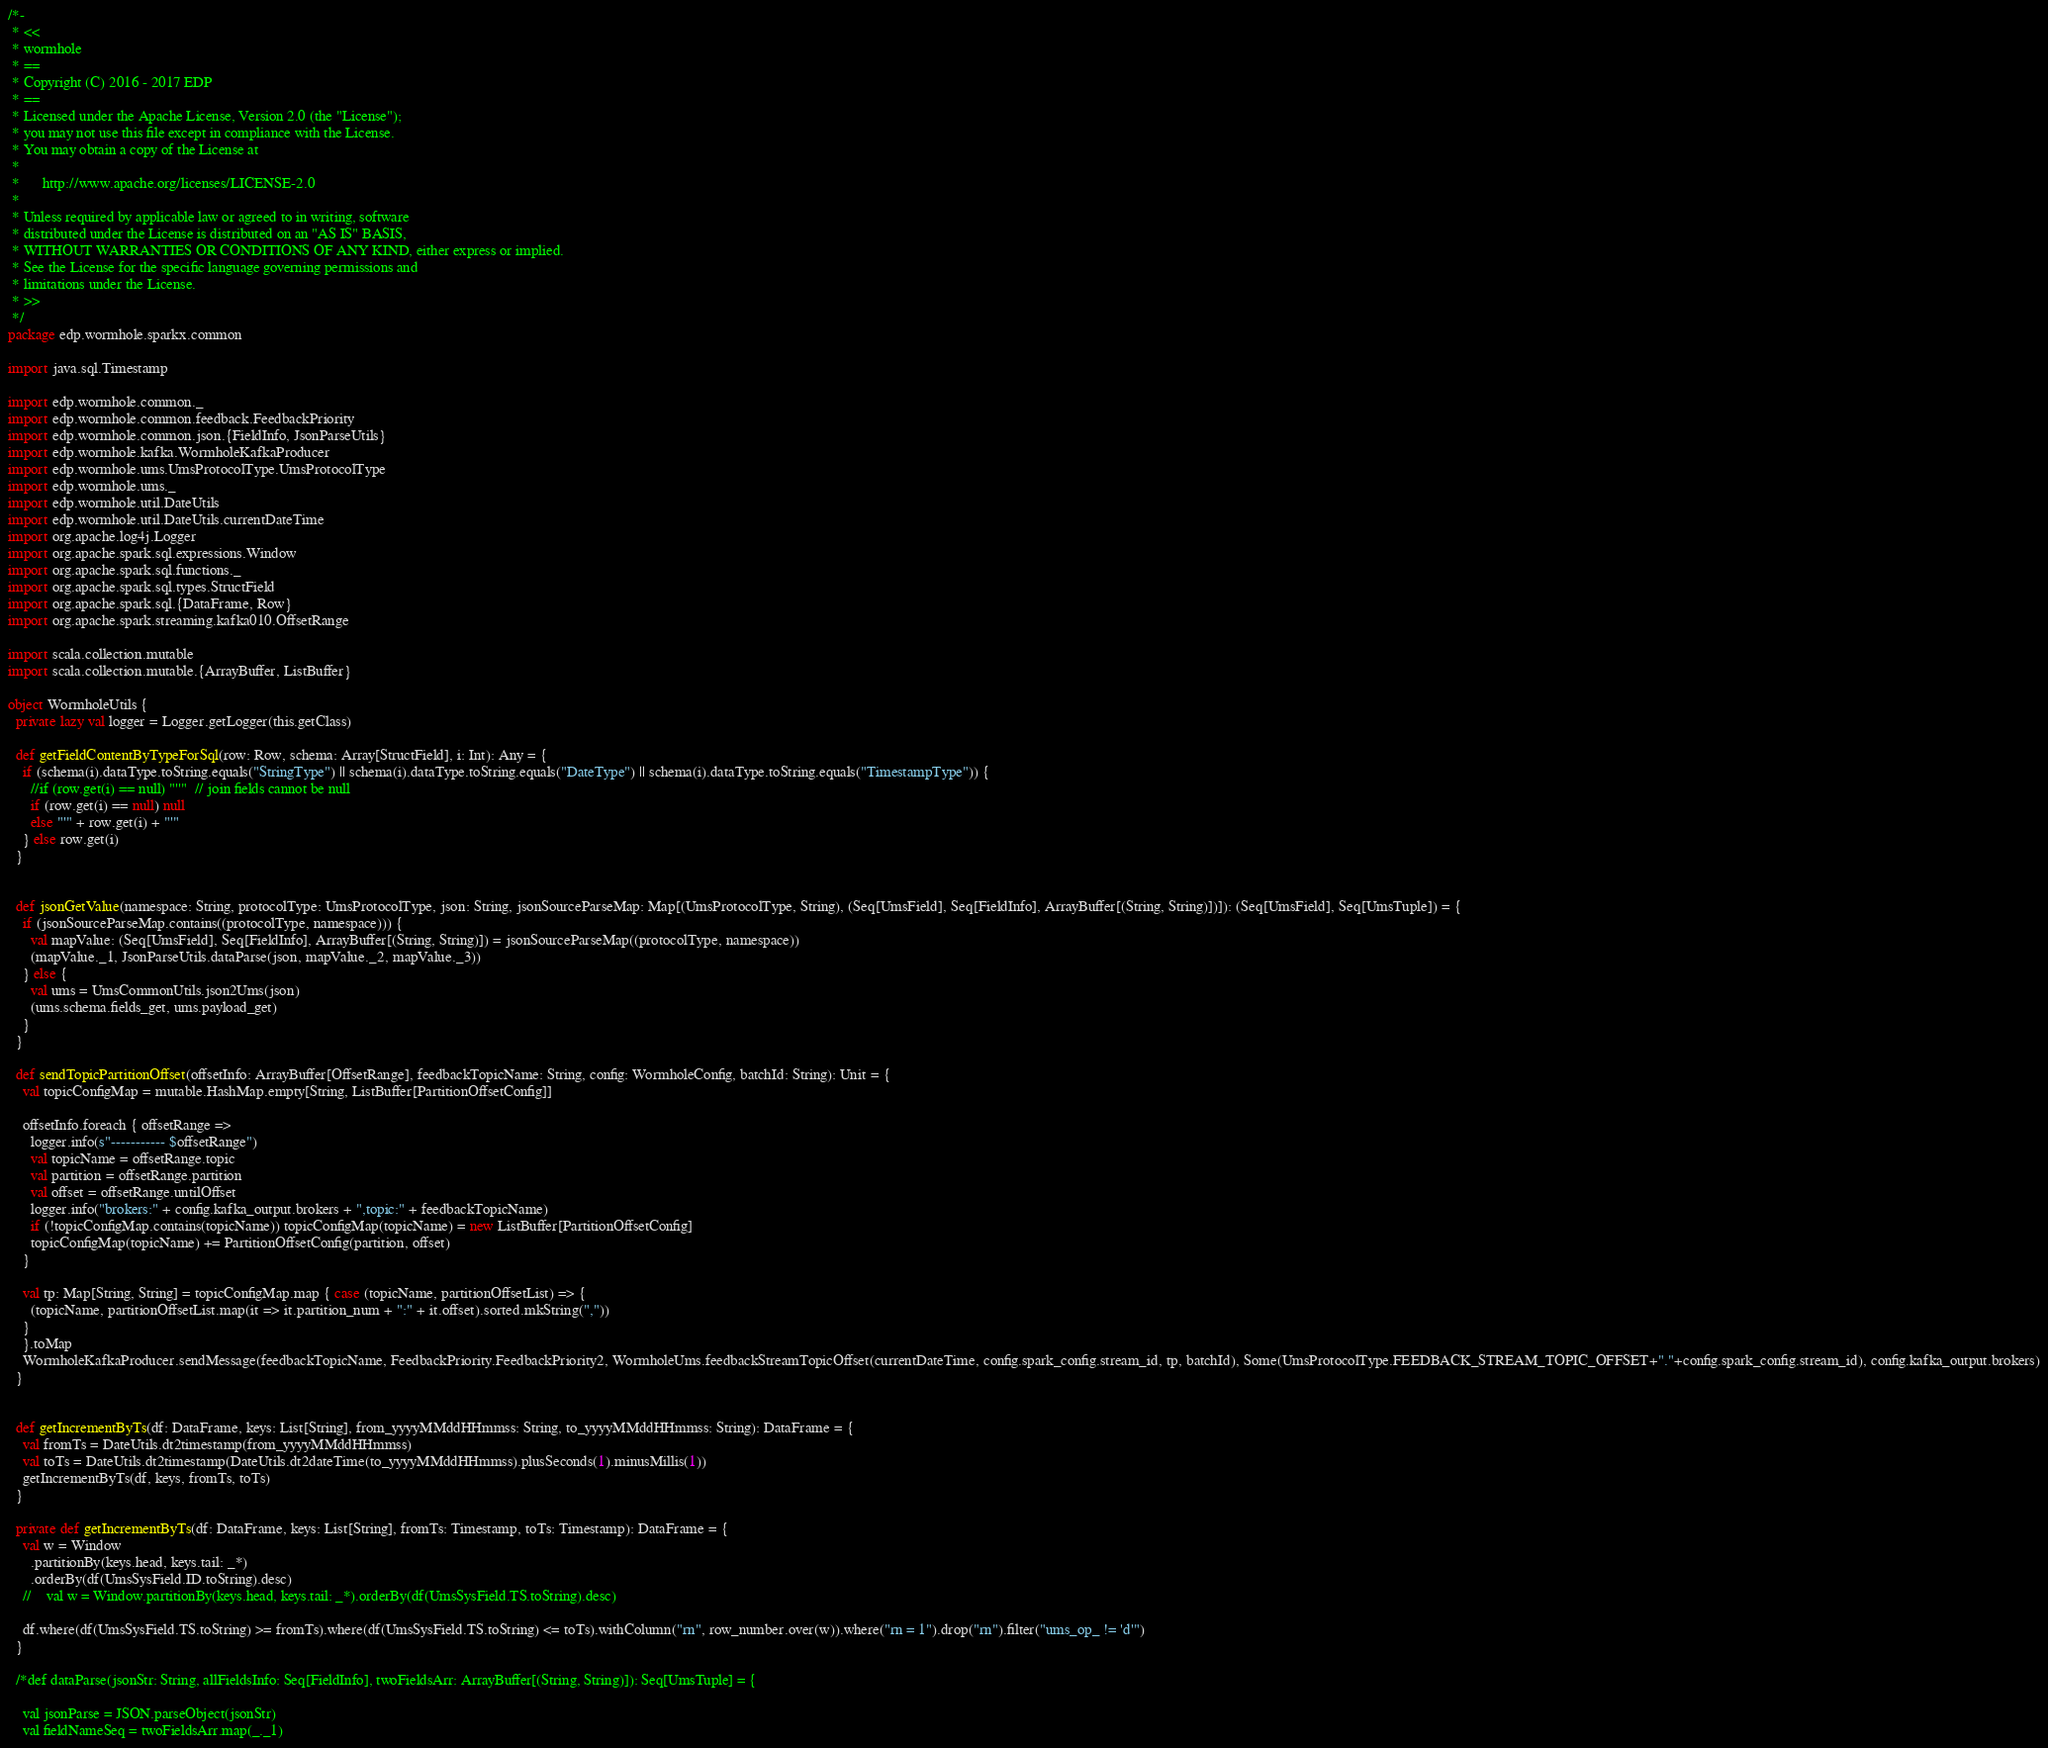Convert code to text. <code><loc_0><loc_0><loc_500><loc_500><_Scala_>/*-
 * <<
 * wormhole
 * ==
 * Copyright (C) 2016 - 2017 EDP
 * ==
 * Licensed under the Apache License, Version 2.0 (the "License");
 * you may not use this file except in compliance with the License.
 * You may obtain a copy of the License at
 *
 *      http://www.apache.org/licenses/LICENSE-2.0
 *
 * Unless required by applicable law or agreed to in writing, software
 * distributed under the License is distributed on an "AS IS" BASIS,
 * WITHOUT WARRANTIES OR CONDITIONS OF ANY KIND, either express or implied.
 * See the License for the specific language governing permissions and
 * limitations under the License.
 * >>
 */
package edp.wormhole.sparkx.common

import java.sql.Timestamp

import edp.wormhole.common._
import edp.wormhole.common.feedback.FeedbackPriority
import edp.wormhole.common.json.{FieldInfo, JsonParseUtils}
import edp.wormhole.kafka.WormholeKafkaProducer
import edp.wormhole.ums.UmsProtocolType.UmsProtocolType
import edp.wormhole.ums._
import edp.wormhole.util.DateUtils
import edp.wormhole.util.DateUtils.currentDateTime
import org.apache.log4j.Logger
import org.apache.spark.sql.expressions.Window
import org.apache.spark.sql.functions._
import org.apache.spark.sql.types.StructField
import org.apache.spark.sql.{DataFrame, Row}
import org.apache.spark.streaming.kafka010.OffsetRange

import scala.collection.mutable
import scala.collection.mutable.{ArrayBuffer, ListBuffer}

object WormholeUtils {
  private lazy val logger = Logger.getLogger(this.getClass)

  def getFieldContentByTypeForSql(row: Row, schema: Array[StructField], i: Int): Any = {
    if (schema(i).dataType.toString.equals("StringType") || schema(i).dataType.toString.equals("DateType") || schema(i).dataType.toString.equals("TimestampType")) {
      //if (row.get(i) == null) "''"  // join fields cannot be null
      if (row.get(i) == null) null
      else "'" + row.get(i) + "'"
    } else row.get(i)
  }


  def jsonGetValue(namespace: String, protocolType: UmsProtocolType, json: String, jsonSourceParseMap: Map[(UmsProtocolType, String), (Seq[UmsField], Seq[FieldInfo], ArrayBuffer[(String, String)])]): (Seq[UmsField], Seq[UmsTuple]) = {
    if (jsonSourceParseMap.contains((protocolType, namespace))) {
      val mapValue: (Seq[UmsField], Seq[FieldInfo], ArrayBuffer[(String, String)]) = jsonSourceParseMap((protocolType, namespace))
      (mapValue._1, JsonParseUtils.dataParse(json, mapValue._2, mapValue._3))
    } else {
      val ums = UmsCommonUtils.json2Ums(json)
      (ums.schema.fields_get, ums.payload_get)
    }
  }

  def sendTopicPartitionOffset(offsetInfo: ArrayBuffer[OffsetRange], feedbackTopicName: String, config: WormholeConfig, batchId: String): Unit = {
    val topicConfigMap = mutable.HashMap.empty[String, ListBuffer[PartitionOffsetConfig]]

    offsetInfo.foreach { offsetRange =>
      logger.info(s"----------- $offsetRange")
      val topicName = offsetRange.topic
      val partition = offsetRange.partition
      val offset = offsetRange.untilOffset
      logger.info("brokers:" + config.kafka_output.brokers + ",topic:" + feedbackTopicName)
      if (!topicConfigMap.contains(topicName)) topicConfigMap(topicName) = new ListBuffer[PartitionOffsetConfig]
      topicConfigMap(topicName) += PartitionOffsetConfig(partition, offset)
    }

    val tp: Map[String, String] = topicConfigMap.map { case (topicName, partitionOffsetList) => {
      (topicName, partitionOffsetList.map(it => it.partition_num + ":" + it.offset).sorted.mkString(","))
    }
    }.toMap
    WormholeKafkaProducer.sendMessage(feedbackTopicName, FeedbackPriority.FeedbackPriority2, WormholeUms.feedbackStreamTopicOffset(currentDateTime, config.spark_config.stream_id, tp, batchId), Some(UmsProtocolType.FEEDBACK_STREAM_TOPIC_OFFSET+"."+config.spark_config.stream_id), config.kafka_output.brokers)
  }


  def getIncrementByTs(df: DataFrame, keys: List[String], from_yyyyMMddHHmmss: String, to_yyyyMMddHHmmss: String): DataFrame = {
    val fromTs = DateUtils.dt2timestamp(from_yyyyMMddHHmmss)
    val toTs = DateUtils.dt2timestamp(DateUtils.dt2dateTime(to_yyyyMMddHHmmss).plusSeconds(1).minusMillis(1))
    getIncrementByTs(df, keys, fromTs, toTs)
  }

  private def getIncrementByTs(df: DataFrame, keys: List[String], fromTs: Timestamp, toTs: Timestamp): DataFrame = {
    val w = Window
      .partitionBy(keys.head, keys.tail: _*)
      .orderBy(df(UmsSysField.ID.toString).desc)
    //    val w = Window.partitionBy(keys.head, keys.tail: _*).orderBy(df(UmsSysField.TS.toString).desc)

    df.where(df(UmsSysField.TS.toString) >= fromTs).where(df(UmsSysField.TS.toString) <= toTs).withColumn("rn", row_number.over(w)).where("rn = 1").drop("rn").filter("ums_op_ != 'd'")
  }

  /*def dataParse(jsonStr: String, allFieldsInfo: Seq[FieldInfo], twoFieldsArr: ArrayBuffer[(String, String)]): Seq[UmsTuple] = {

    val jsonParse = JSON.parseObject(jsonStr)
    val fieldNameSeq = twoFieldsArr.map(_._1)</code> 